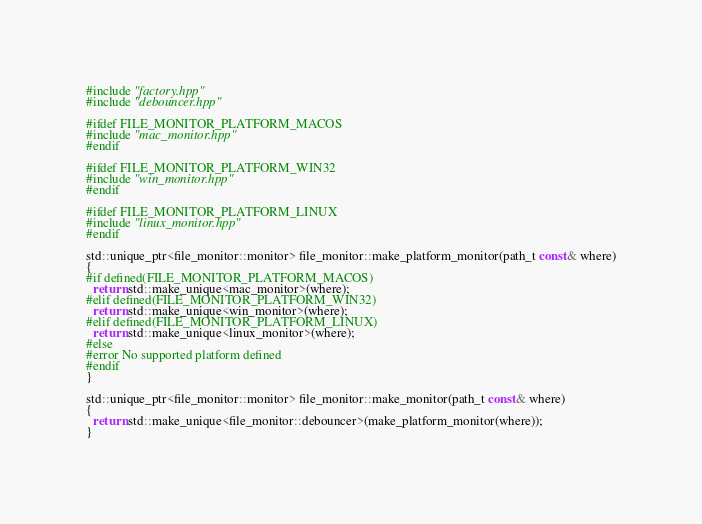<code> <loc_0><loc_0><loc_500><loc_500><_C++_>#include "factory.hpp"
#include "debouncer.hpp"

#ifdef FILE_MONITOR_PLATFORM_MACOS
#include "mac_monitor.hpp"
#endif

#ifdef FILE_MONITOR_PLATFORM_WIN32
#include "win_monitor.hpp"
#endif

#ifdef FILE_MONITOR_PLATFORM_LINUX
#include "linux_monitor.hpp"
#endif

std::unique_ptr<file_monitor::monitor> file_monitor::make_platform_monitor(path_t const& where)
{
#if defined(FILE_MONITOR_PLATFORM_MACOS)
  return std::make_unique<mac_monitor>(where);
#elif defined(FILE_MONITOR_PLATFORM_WIN32)
  return std::make_unique<win_monitor>(where);
#elif defined(FILE_MONITOR_PLATFORM_LINUX)
  return std::make_unique<linux_monitor>(where);
#else
#error No supported platform defined
#endif
}

std::unique_ptr<file_monitor::monitor> file_monitor::make_monitor(path_t const& where)
{
  return std::make_unique<file_monitor::debouncer>(make_platform_monitor(where));
}
</code> 